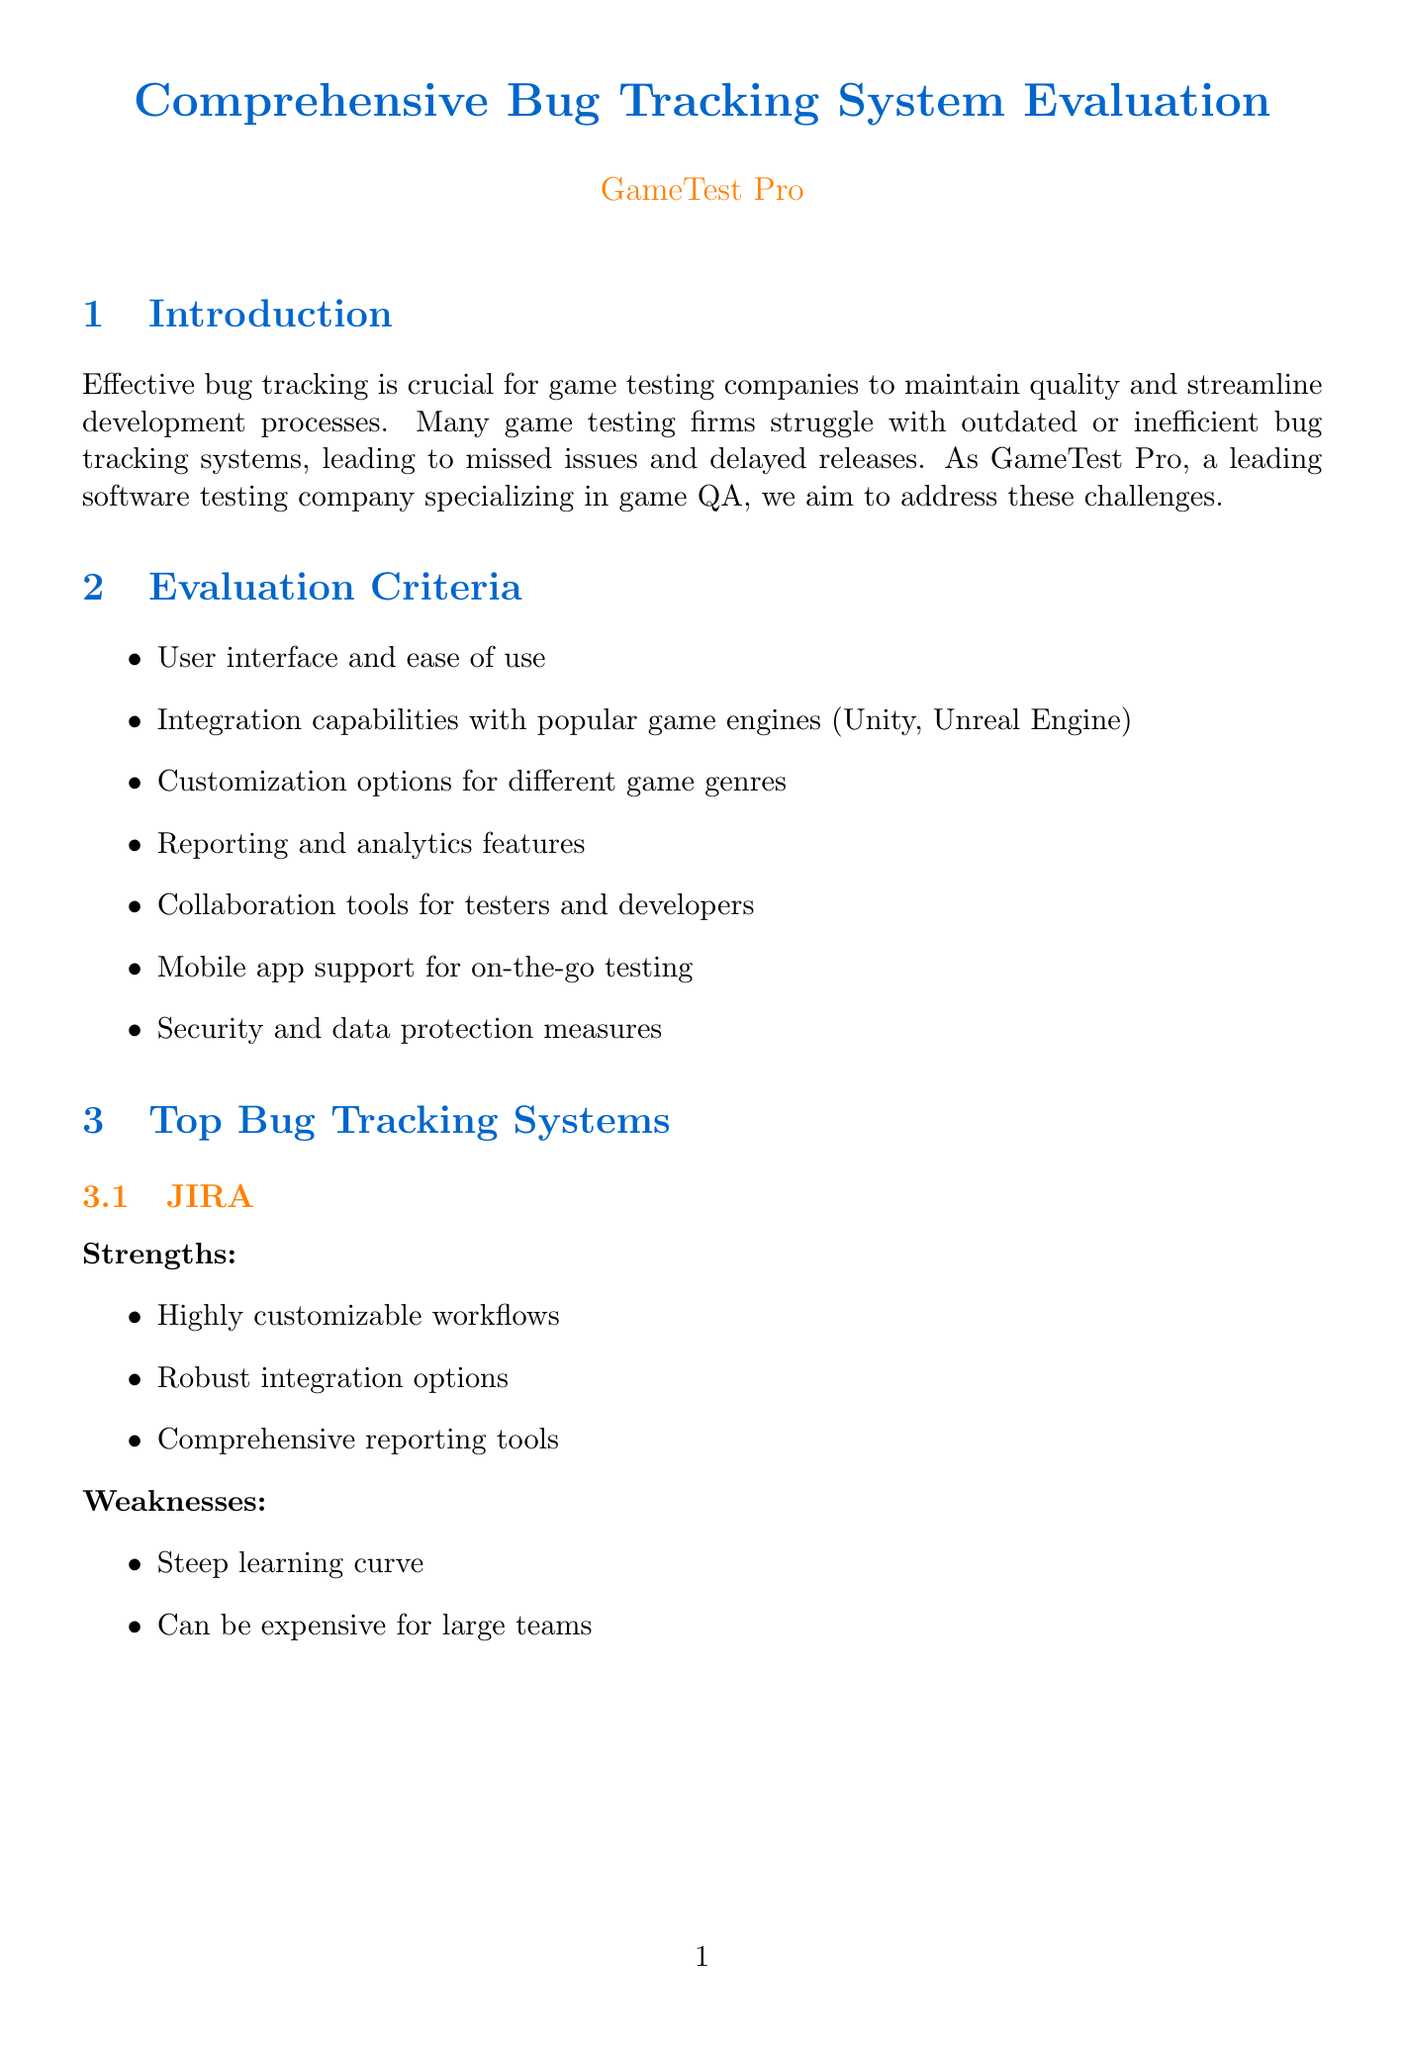What are the evaluation criteria for bug tracking systems? The document lists specific criteria used for evaluating bug tracking systems, such as user interface and ease of use, integration capabilities, and more.
Answer: User interface and ease of use, Integration capabilities with popular game engines (Unity, Unreal Engine), Customization options for different game genres, Reporting and analytics features, Collaboration tools for testers and developers, Mobile app support for on-the-go testing, Security and data protection measures What is a strength of JIRA? The document highlights specific strengths associated with JIRA, including its highly customizable workflows and robust integration options.
Answer: Highly customizable workflows What percentage reduction in critical bugs did Ubisoft achieve? The success metric for Ubisoft's implementation of JIRA is stated in the document, which shows the effectiveness of their solution.
Answer: 30% What game-specific feature helps with performance metrics? The document mentions several game-specific features, one of which relates to logging performance metrics, specifically FPS and memory usage.
Answer: Performance metrics logging (FPS, memory usage) What is one recommendation made for improving bug tracking systems? The document provides several recommendations for enhancing bug tracking; one notable approach involves implementing AI-powered bug prediction.
Answer: Implement AI-powered bug prediction Which system is highlighted as open-source and cost-effective? The evaluation of bug tracking systems includes characteristics that Mantis, as stated in the document, is an open-source and cost-effective solution.
Answer: Mantis What challenge did Rovio face in their bug tracking efforts? The document describes the specific challenges faced by Rovio during their bug tracking process, emphasizing coordination issues.
Answer: Coordinating bug tracking across global QA teams What benefit does enhancing cross-platform testing capabilities provide? The document outlines the benefits associated with improving cross-platform testing, emphasizing efficiency in game testing.
Answer: Improve efficiency in multi-platform game testing What is the overall call to action from GameTest Pro? The document concludes with a specific commitment from GameTest Pro regarding the focus on bug tracking technology and improved game testing services.
Answer: GameTest Pro is committed to staying at the forefront of bug tracking technology to deliver superior game testing services 